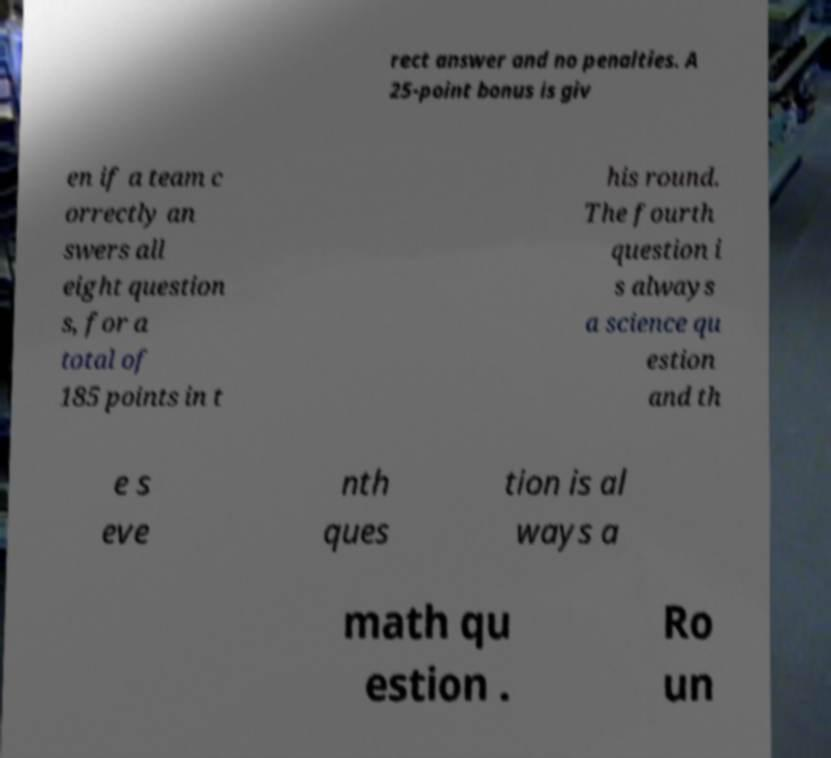Please read and relay the text visible in this image. What does it say? rect answer and no penalties. A 25-point bonus is giv en if a team c orrectly an swers all eight question s, for a total of 185 points in t his round. The fourth question i s always a science qu estion and th e s eve nth ques tion is al ways a math qu estion . Ro un 